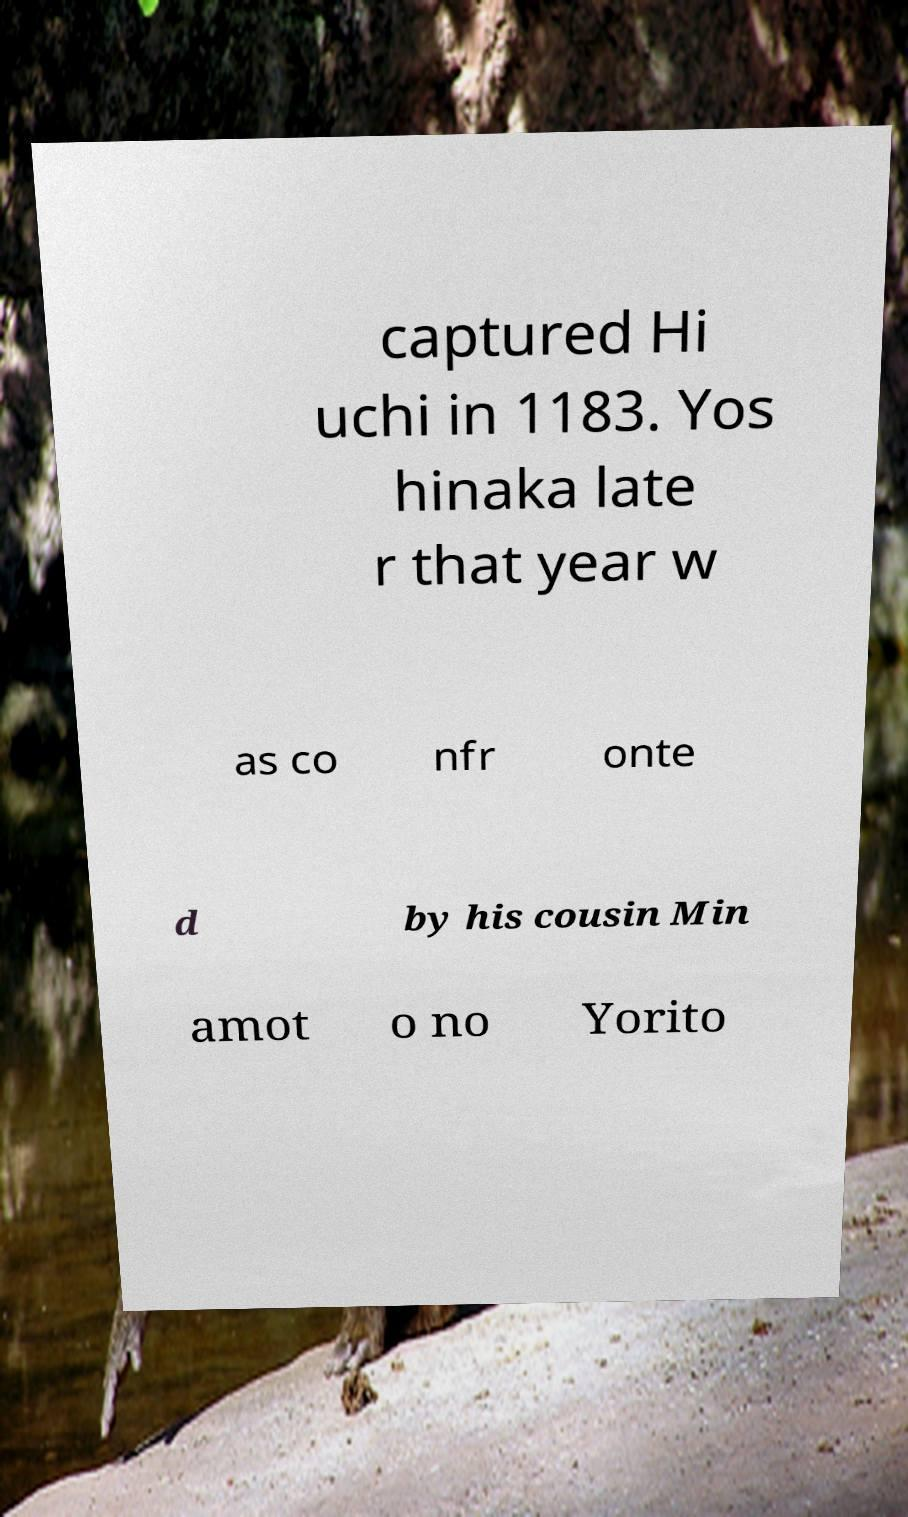Could you assist in decoding the text presented in this image and type it out clearly? captured Hi uchi in 1183. Yos hinaka late r that year w as co nfr onte d by his cousin Min amot o no Yorito 